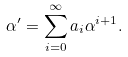Convert formula to latex. <formula><loc_0><loc_0><loc_500><loc_500>\alpha ^ { \prime } = \sum _ { i = 0 } ^ { \infty } a _ { i } \alpha ^ { i + 1 } .</formula> 